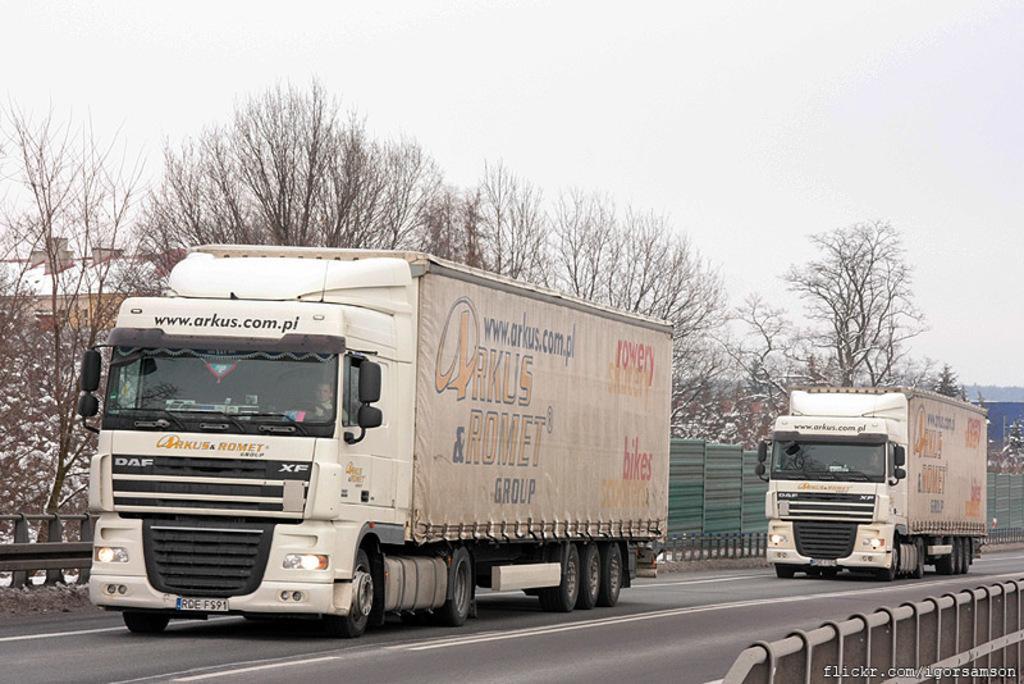Describe this image in one or two sentences. There are two trucks on the road as we can see in the middle of this image, and there is a fence and some trees in the background. There is a sky at the top of this image. 